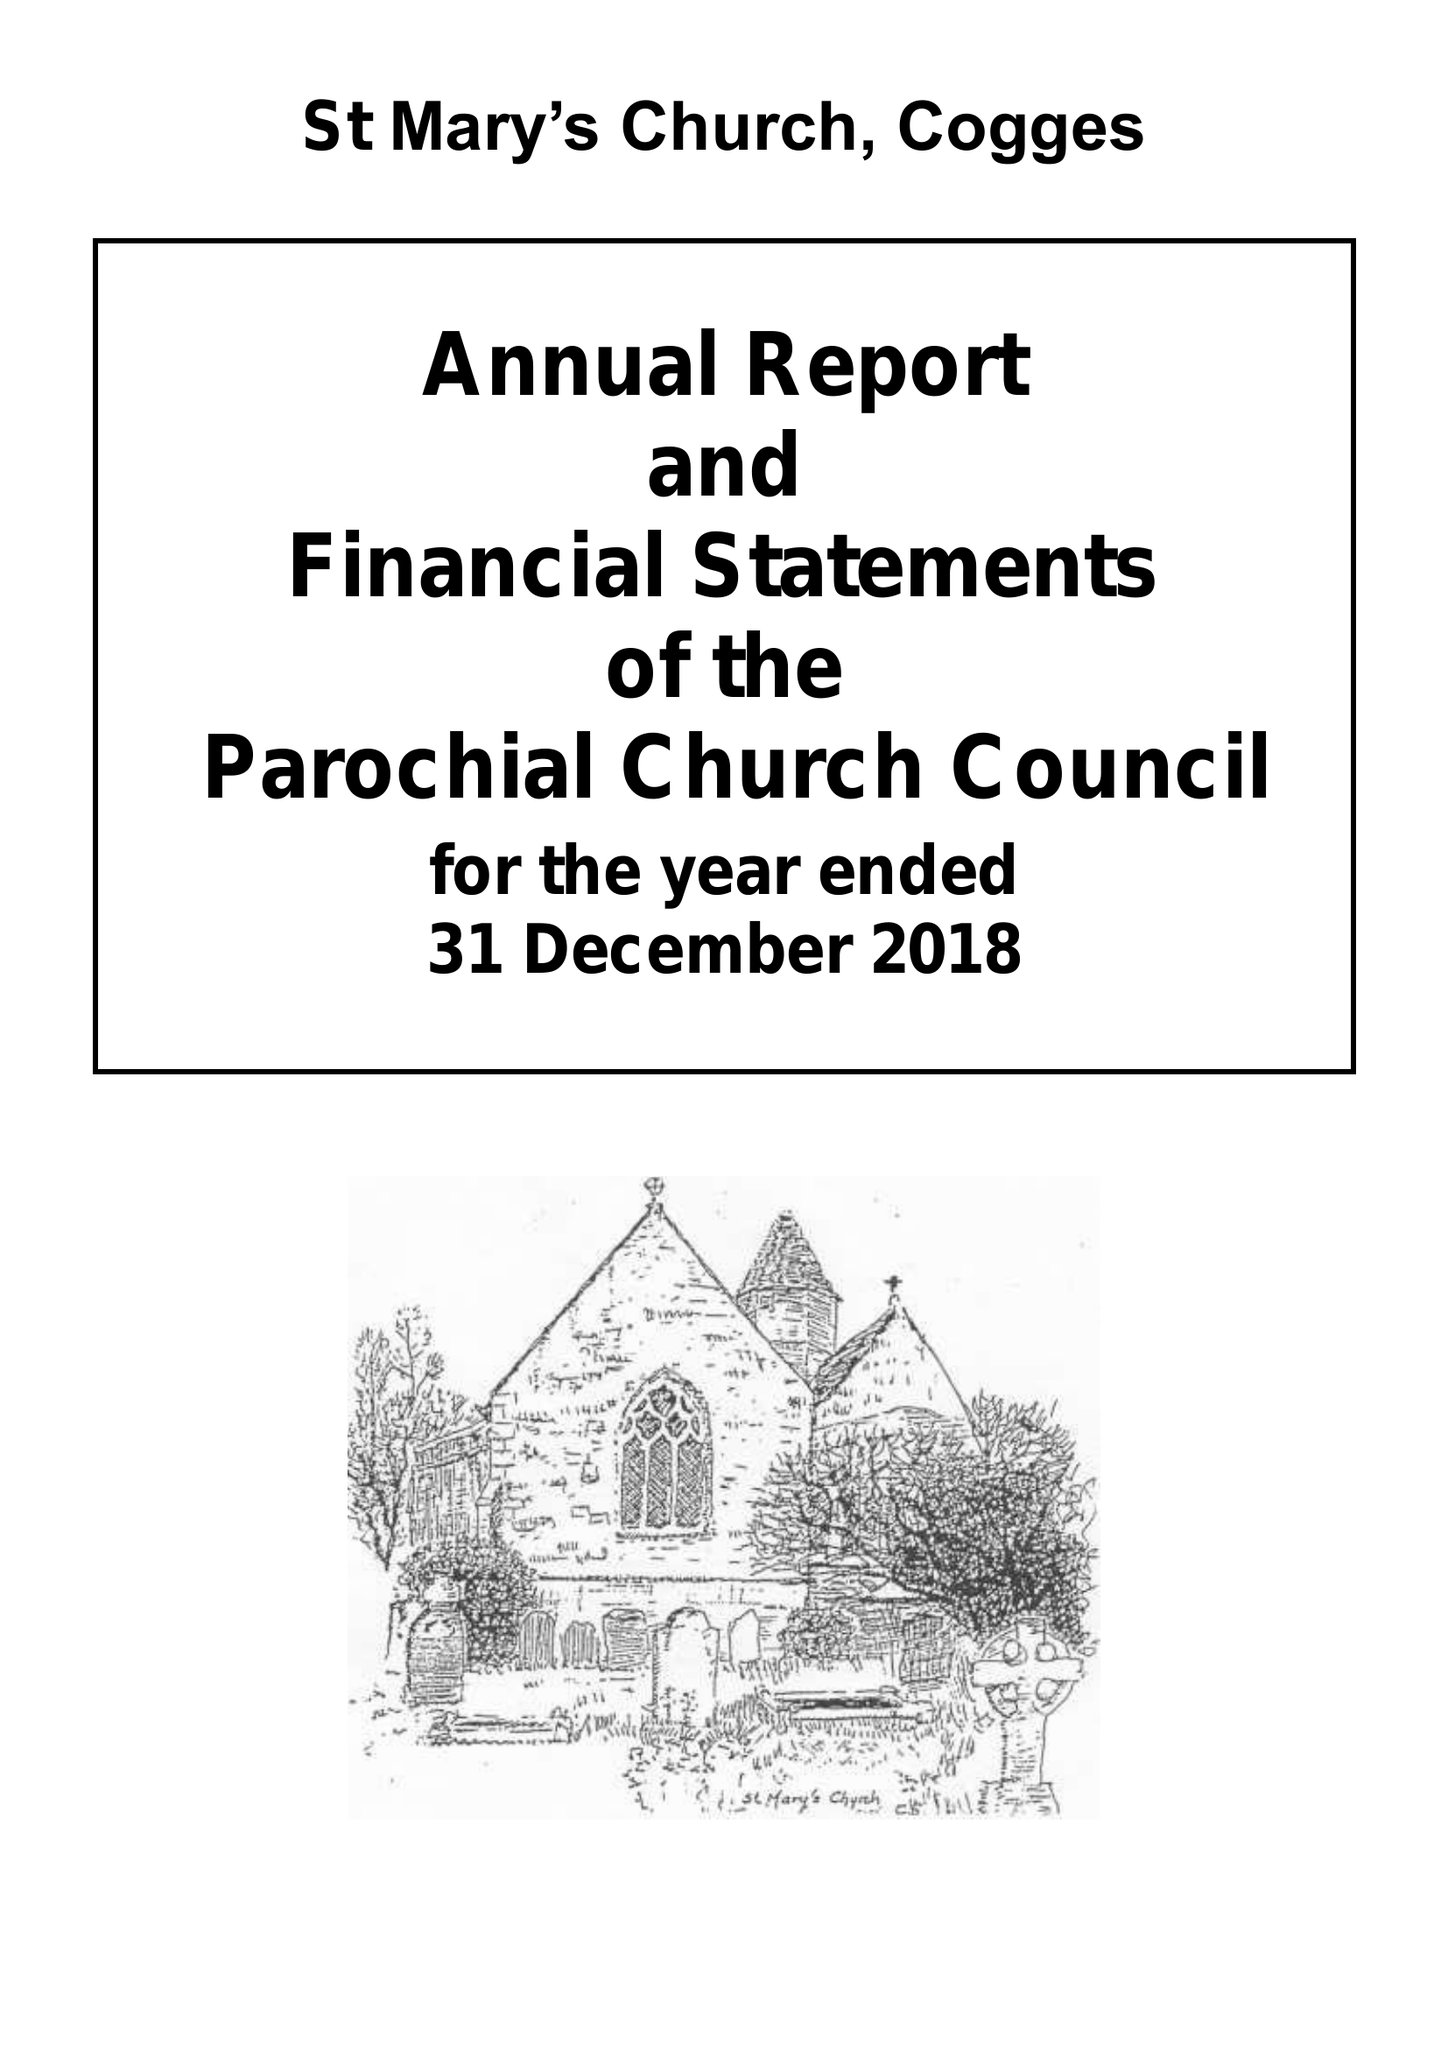What is the value for the address__postcode?
Answer the question using a single word or phrase. OX28 3LA 